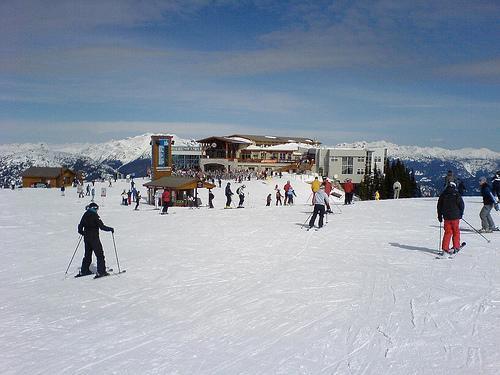How many people have red pants?
Give a very brief answer. 1. 